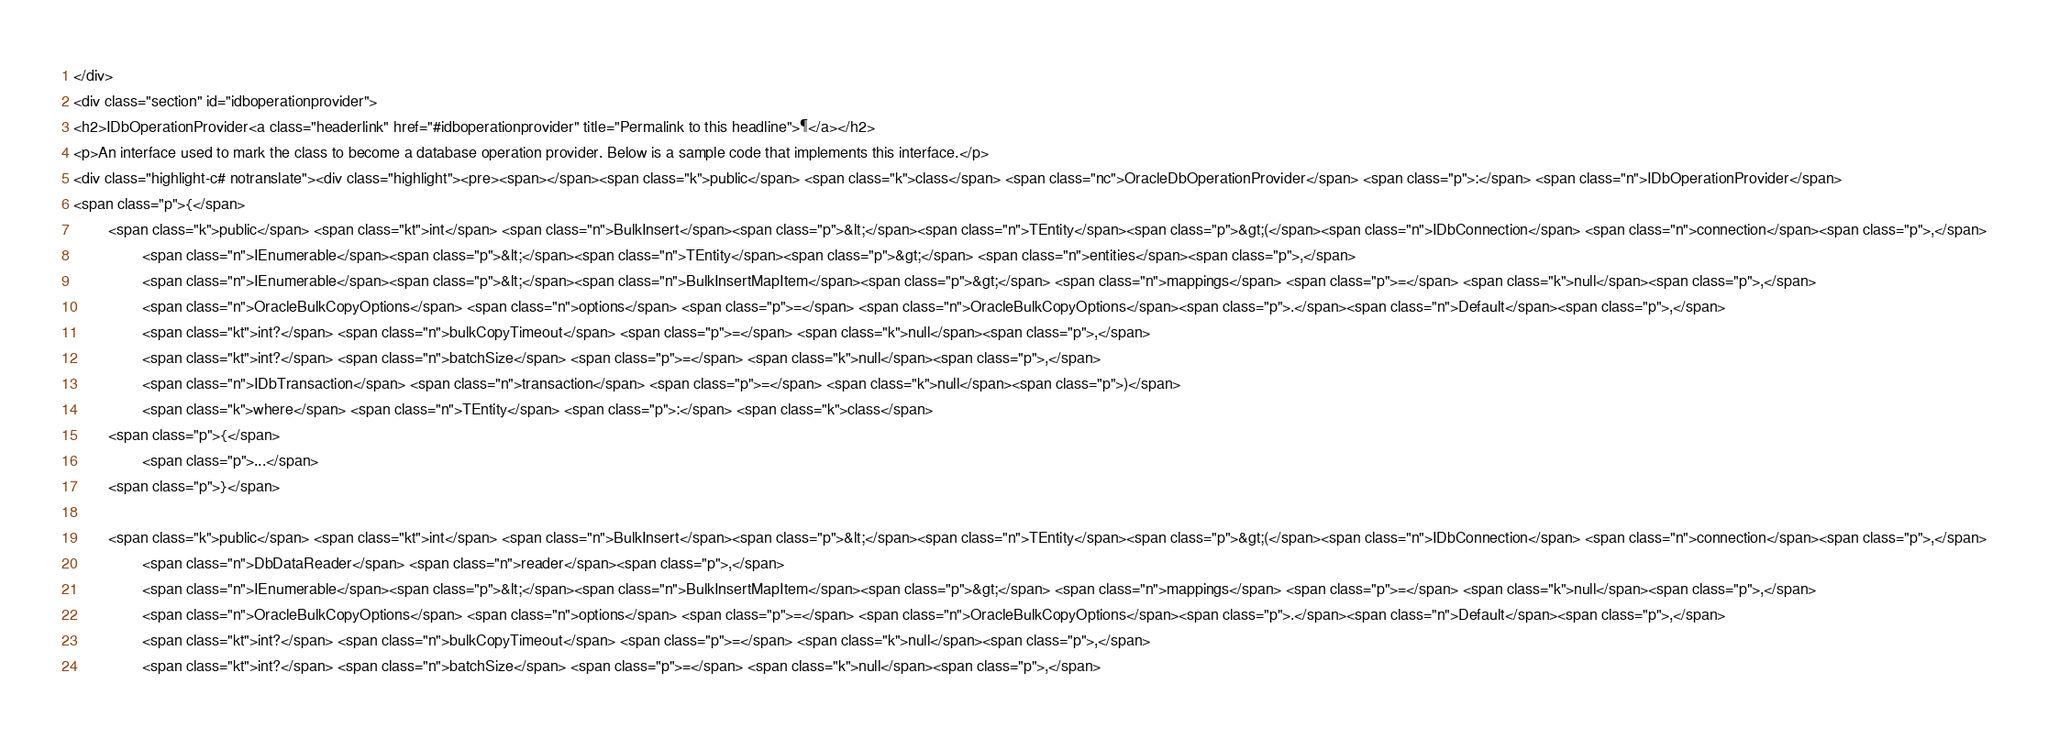<code> <loc_0><loc_0><loc_500><loc_500><_HTML_></div>
<div class="section" id="idboperationprovider">
<h2>IDbOperationProvider<a class="headerlink" href="#idboperationprovider" title="Permalink to this headline">¶</a></h2>
<p>An interface used to mark the class to become a database operation provider. Below is a sample code that implements this interface.</p>
<div class="highlight-c# notranslate"><div class="highlight"><pre><span></span><span class="k">public</span> <span class="k">class</span> <span class="nc">OracleDbOperationProvider</span> <span class="p">:</span> <span class="n">IDbOperationProvider</span>
<span class="p">{</span>
        <span class="k">public</span> <span class="kt">int</span> <span class="n">BulkInsert</span><span class="p">&lt;</span><span class="n">TEntity</span><span class="p">&gt;(</span><span class="n">IDbConnection</span> <span class="n">connection</span><span class="p">,</span>
                <span class="n">IEnumerable</span><span class="p">&lt;</span><span class="n">TEntity</span><span class="p">&gt;</span> <span class="n">entities</span><span class="p">,</span>
                <span class="n">IEnumerable</span><span class="p">&lt;</span><span class="n">BulkInsertMapItem</span><span class="p">&gt;</span> <span class="n">mappings</span> <span class="p">=</span> <span class="k">null</span><span class="p">,</span>
                <span class="n">OracleBulkCopyOptions</span> <span class="n">options</span> <span class="p">=</span> <span class="n">OracleBulkCopyOptions</span><span class="p">.</span><span class="n">Default</span><span class="p">,</span>
                <span class="kt">int?</span> <span class="n">bulkCopyTimeout</span> <span class="p">=</span> <span class="k">null</span><span class="p">,</span>
                <span class="kt">int?</span> <span class="n">batchSize</span> <span class="p">=</span> <span class="k">null</span><span class="p">,</span>
                <span class="n">IDbTransaction</span> <span class="n">transaction</span> <span class="p">=</span> <span class="k">null</span><span class="p">)</span>
                <span class="k">where</span> <span class="n">TEntity</span> <span class="p">:</span> <span class="k">class</span>
        <span class="p">{</span>
                <span class="p">...</span>
        <span class="p">}</span>

        <span class="k">public</span> <span class="kt">int</span> <span class="n">BulkInsert</span><span class="p">&lt;</span><span class="n">TEntity</span><span class="p">&gt;(</span><span class="n">IDbConnection</span> <span class="n">connection</span><span class="p">,</span>
                <span class="n">DbDataReader</span> <span class="n">reader</span><span class="p">,</span>
                <span class="n">IEnumerable</span><span class="p">&lt;</span><span class="n">BulkInsertMapItem</span><span class="p">&gt;</span> <span class="n">mappings</span> <span class="p">=</span> <span class="k">null</span><span class="p">,</span>
                <span class="n">OracleBulkCopyOptions</span> <span class="n">options</span> <span class="p">=</span> <span class="n">OracleBulkCopyOptions</span><span class="p">.</span><span class="n">Default</span><span class="p">,</span>
                <span class="kt">int?</span> <span class="n">bulkCopyTimeout</span> <span class="p">=</span> <span class="k">null</span><span class="p">,</span>
                <span class="kt">int?</span> <span class="n">batchSize</span> <span class="p">=</span> <span class="k">null</span><span class="p">,</span></code> 